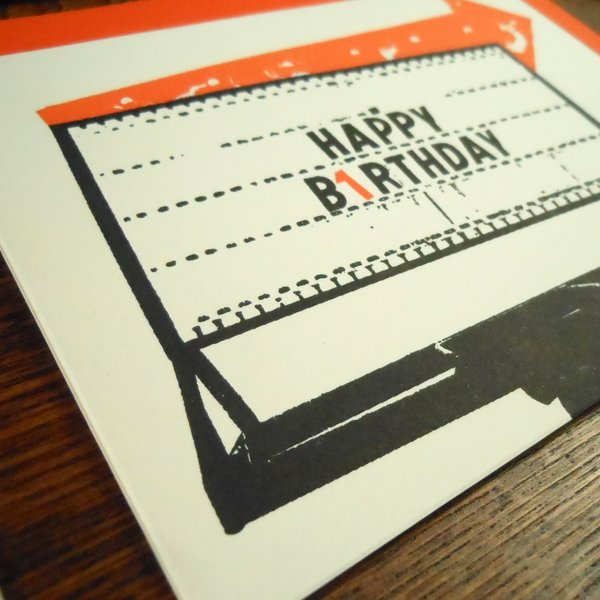What if this card were part of a movie scene? How would it contribute to the storyline? In a movie scene, this vintage birthday card could serve as a poignant plot device, adding depth and nostalgia to the storyline. Imagine a character receiving this card in a scene set in the present day, sent by an old friend or relative, evoking memories of past times and shared experiences. The retro design and typewriter font could symbolize a connection to earlier years, triggering a series of flashbacks or a journey to reconnect with someone significant from their past. The smudge effect could represent the imperfect but meaningful relationships and moments that shape the protagonist's life. This card could be a catalyst for emotional reflection or a turning point that drives the character to make important decisions, adding layers of meaning to the narrative. What are the realistic scenarios in which this card might be given? One realistic scenario is of a grandparent giving this card to their grandchild, capturing the essence of a past era they fondly remember. The grandparent might share stories about how they used typewriters, adding a personal and historical touch to the birthday greeting. Another scenario could be a friend who loves vintage items giving it to someone with a similar interest, making the card not only a birthday wish but also a delightful piece of memorabilia. Additionally, a person might choose this card for a significant other to express their unique taste and appreciation for retro aesthetics, adding a layer of romantic sentiment to the birthday message. 